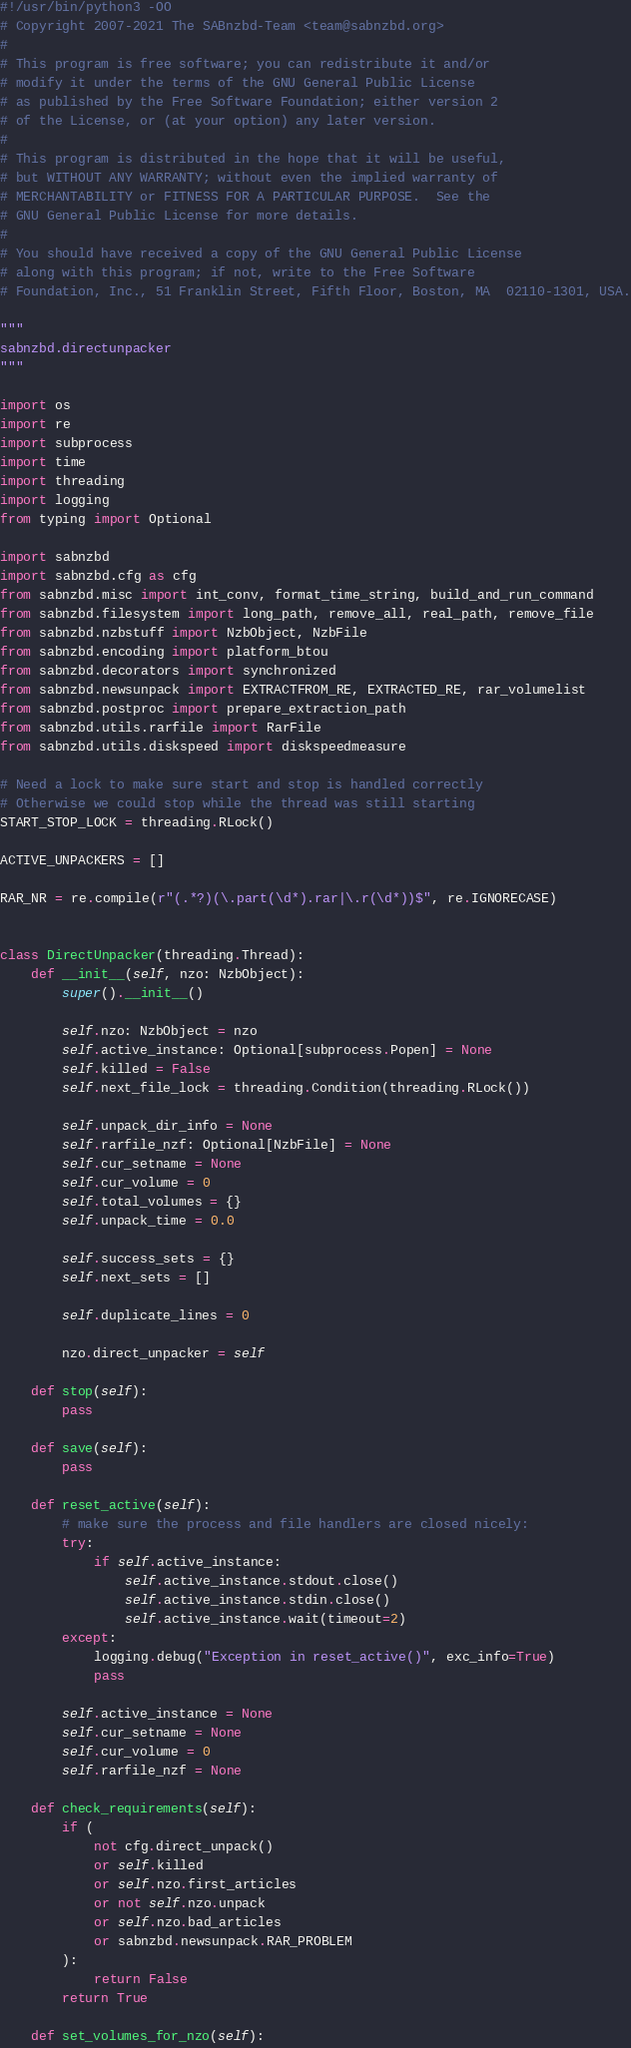<code> <loc_0><loc_0><loc_500><loc_500><_Python_>#!/usr/bin/python3 -OO
# Copyright 2007-2021 The SABnzbd-Team <team@sabnzbd.org>
#
# This program is free software; you can redistribute it and/or
# modify it under the terms of the GNU General Public License
# as published by the Free Software Foundation; either version 2
# of the License, or (at your option) any later version.
#
# This program is distributed in the hope that it will be useful,
# but WITHOUT ANY WARRANTY; without even the implied warranty of
# MERCHANTABILITY or FITNESS FOR A PARTICULAR PURPOSE.  See the
# GNU General Public License for more details.
#
# You should have received a copy of the GNU General Public License
# along with this program; if not, write to the Free Software
# Foundation, Inc., 51 Franklin Street, Fifth Floor, Boston, MA  02110-1301, USA.

"""
sabnzbd.directunpacker
"""

import os
import re
import subprocess
import time
import threading
import logging
from typing import Optional

import sabnzbd
import sabnzbd.cfg as cfg
from sabnzbd.misc import int_conv, format_time_string, build_and_run_command
from sabnzbd.filesystem import long_path, remove_all, real_path, remove_file
from sabnzbd.nzbstuff import NzbObject, NzbFile
from sabnzbd.encoding import platform_btou
from sabnzbd.decorators import synchronized
from sabnzbd.newsunpack import EXTRACTFROM_RE, EXTRACTED_RE, rar_volumelist
from sabnzbd.postproc import prepare_extraction_path
from sabnzbd.utils.rarfile import RarFile
from sabnzbd.utils.diskspeed import diskspeedmeasure

# Need a lock to make sure start and stop is handled correctly
# Otherwise we could stop while the thread was still starting
START_STOP_LOCK = threading.RLock()

ACTIVE_UNPACKERS = []

RAR_NR = re.compile(r"(.*?)(\.part(\d*).rar|\.r(\d*))$", re.IGNORECASE)


class DirectUnpacker(threading.Thread):
    def __init__(self, nzo: NzbObject):
        super().__init__()

        self.nzo: NzbObject = nzo
        self.active_instance: Optional[subprocess.Popen] = None
        self.killed = False
        self.next_file_lock = threading.Condition(threading.RLock())

        self.unpack_dir_info = None
        self.rarfile_nzf: Optional[NzbFile] = None
        self.cur_setname = None
        self.cur_volume = 0
        self.total_volumes = {}
        self.unpack_time = 0.0

        self.success_sets = {}
        self.next_sets = []

        self.duplicate_lines = 0

        nzo.direct_unpacker = self

    def stop(self):
        pass

    def save(self):
        pass

    def reset_active(self):
        # make sure the process and file handlers are closed nicely:
        try:
            if self.active_instance:
                self.active_instance.stdout.close()
                self.active_instance.stdin.close()
                self.active_instance.wait(timeout=2)
        except:
            logging.debug("Exception in reset_active()", exc_info=True)
            pass

        self.active_instance = None
        self.cur_setname = None
        self.cur_volume = 0
        self.rarfile_nzf = None

    def check_requirements(self):
        if (
            not cfg.direct_unpack()
            or self.killed
            or self.nzo.first_articles
            or not self.nzo.unpack
            or self.nzo.bad_articles
            or sabnzbd.newsunpack.RAR_PROBLEM
        ):
            return False
        return True

    def set_volumes_for_nzo(self):</code> 